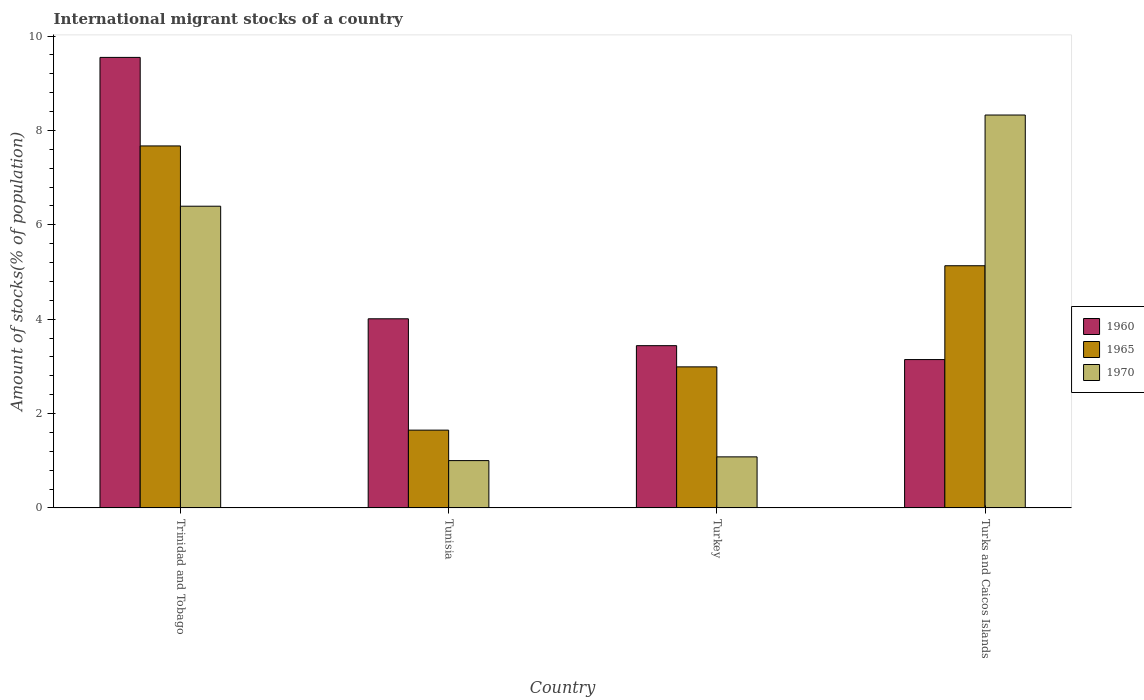How many different coloured bars are there?
Give a very brief answer. 3. How many groups of bars are there?
Ensure brevity in your answer.  4. Are the number of bars on each tick of the X-axis equal?
Offer a very short reply. Yes. What is the label of the 4th group of bars from the left?
Offer a very short reply. Turks and Caicos Islands. In how many cases, is the number of bars for a given country not equal to the number of legend labels?
Offer a terse response. 0. What is the amount of stocks in in 1965 in Trinidad and Tobago?
Your answer should be very brief. 7.67. Across all countries, what is the maximum amount of stocks in in 1960?
Your response must be concise. 9.55. Across all countries, what is the minimum amount of stocks in in 1960?
Give a very brief answer. 3.14. In which country was the amount of stocks in in 1965 maximum?
Ensure brevity in your answer.  Trinidad and Tobago. In which country was the amount of stocks in in 1960 minimum?
Give a very brief answer. Turks and Caicos Islands. What is the total amount of stocks in in 1960 in the graph?
Keep it short and to the point. 20.14. What is the difference between the amount of stocks in in 1960 in Tunisia and that in Turks and Caicos Islands?
Offer a terse response. 0.86. What is the difference between the amount of stocks in in 1970 in Turkey and the amount of stocks in in 1960 in Turks and Caicos Islands?
Offer a terse response. -2.06. What is the average amount of stocks in in 1965 per country?
Ensure brevity in your answer.  4.36. What is the difference between the amount of stocks in of/in 1960 and amount of stocks in of/in 1965 in Tunisia?
Ensure brevity in your answer.  2.36. What is the ratio of the amount of stocks in in 1960 in Trinidad and Tobago to that in Turkey?
Your answer should be compact. 2.78. What is the difference between the highest and the second highest amount of stocks in in 1965?
Provide a succinct answer. -2.14. What is the difference between the highest and the lowest amount of stocks in in 1960?
Provide a short and direct response. 6.4. What does the 2nd bar from the left in Tunisia represents?
Provide a short and direct response. 1965. What does the 3rd bar from the right in Tunisia represents?
Your response must be concise. 1960. Does the graph contain any zero values?
Provide a succinct answer. No. Where does the legend appear in the graph?
Provide a succinct answer. Center right. How many legend labels are there?
Ensure brevity in your answer.  3. What is the title of the graph?
Keep it short and to the point. International migrant stocks of a country. What is the label or title of the X-axis?
Offer a terse response. Country. What is the label or title of the Y-axis?
Ensure brevity in your answer.  Amount of stocks(% of population). What is the Amount of stocks(% of population) in 1960 in Trinidad and Tobago?
Your answer should be compact. 9.55. What is the Amount of stocks(% of population) in 1965 in Trinidad and Tobago?
Give a very brief answer. 7.67. What is the Amount of stocks(% of population) of 1970 in Trinidad and Tobago?
Your answer should be very brief. 6.39. What is the Amount of stocks(% of population) in 1960 in Tunisia?
Keep it short and to the point. 4.01. What is the Amount of stocks(% of population) of 1965 in Tunisia?
Ensure brevity in your answer.  1.65. What is the Amount of stocks(% of population) of 1970 in Tunisia?
Your answer should be compact. 1. What is the Amount of stocks(% of population) of 1960 in Turkey?
Offer a very short reply. 3.44. What is the Amount of stocks(% of population) of 1965 in Turkey?
Keep it short and to the point. 2.99. What is the Amount of stocks(% of population) in 1970 in Turkey?
Provide a short and direct response. 1.08. What is the Amount of stocks(% of population) of 1960 in Turks and Caicos Islands?
Ensure brevity in your answer.  3.14. What is the Amount of stocks(% of population) of 1965 in Turks and Caicos Islands?
Make the answer very short. 5.13. What is the Amount of stocks(% of population) of 1970 in Turks and Caicos Islands?
Provide a succinct answer. 8.33. Across all countries, what is the maximum Amount of stocks(% of population) of 1960?
Offer a terse response. 9.55. Across all countries, what is the maximum Amount of stocks(% of population) of 1965?
Ensure brevity in your answer.  7.67. Across all countries, what is the maximum Amount of stocks(% of population) of 1970?
Make the answer very short. 8.33. Across all countries, what is the minimum Amount of stocks(% of population) in 1960?
Give a very brief answer. 3.14. Across all countries, what is the minimum Amount of stocks(% of population) in 1965?
Provide a succinct answer. 1.65. Across all countries, what is the minimum Amount of stocks(% of population) in 1970?
Keep it short and to the point. 1. What is the total Amount of stocks(% of population) in 1960 in the graph?
Give a very brief answer. 20.14. What is the total Amount of stocks(% of population) of 1965 in the graph?
Offer a very short reply. 17.44. What is the total Amount of stocks(% of population) of 1970 in the graph?
Offer a very short reply. 16.81. What is the difference between the Amount of stocks(% of population) of 1960 in Trinidad and Tobago and that in Tunisia?
Ensure brevity in your answer.  5.54. What is the difference between the Amount of stocks(% of population) of 1965 in Trinidad and Tobago and that in Tunisia?
Offer a terse response. 6.02. What is the difference between the Amount of stocks(% of population) in 1970 in Trinidad and Tobago and that in Tunisia?
Offer a terse response. 5.39. What is the difference between the Amount of stocks(% of population) in 1960 in Trinidad and Tobago and that in Turkey?
Make the answer very short. 6.11. What is the difference between the Amount of stocks(% of population) in 1965 in Trinidad and Tobago and that in Turkey?
Your response must be concise. 4.68. What is the difference between the Amount of stocks(% of population) in 1970 in Trinidad and Tobago and that in Turkey?
Offer a terse response. 5.31. What is the difference between the Amount of stocks(% of population) of 1960 in Trinidad and Tobago and that in Turks and Caicos Islands?
Your answer should be compact. 6.4. What is the difference between the Amount of stocks(% of population) of 1965 in Trinidad and Tobago and that in Turks and Caicos Islands?
Offer a terse response. 2.54. What is the difference between the Amount of stocks(% of population) in 1970 in Trinidad and Tobago and that in Turks and Caicos Islands?
Your answer should be very brief. -1.93. What is the difference between the Amount of stocks(% of population) in 1960 in Tunisia and that in Turkey?
Your answer should be very brief. 0.57. What is the difference between the Amount of stocks(% of population) of 1965 in Tunisia and that in Turkey?
Give a very brief answer. -1.34. What is the difference between the Amount of stocks(% of population) in 1970 in Tunisia and that in Turkey?
Provide a short and direct response. -0.08. What is the difference between the Amount of stocks(% of population) of 1960 in Tunisia and that in Turks and Caicos Islands?
Your answer should be compact. 0.86. What is the difference between the Amount of stocks(% of population) in 1965 in Tunisia and that in Turks and Caicos Islands?
Your answer should be compact. -3.48. What is the difference between the Amount of stocks(% of population) of 1970 in Tunisia and that in Turks and Caicos Islands?
Ensure brevity in your answer.  -7.32. What is the difference between the Amount of stocks(% of population) of 1960 in Turkey and that in Turks and Caicos Islands?
Keep it short and to the point. 0.29. What is the difference between the Amount of stocks(% of population) in 1965 in Turkey and that in Turks and Caicos Islands?
Offer a very short reply. -2.14. What is the difference between the Amount of stocks(% of population) in 1970 in Turkey and that in Turks and Caicos Islands?
Offer a very short reply. -7.25. What is the difference between the Amount of stocks(% of population) of 1960 in Trinidad and Tobago and the Amount of stocks(% of population) of 1965 in Tunisia?
Offer a very short reply. 7.9. What is the difference between the Amount of stocks(% of population) in 1960 in Trinidad and Tobago and the Amount of stocks(% of population) in 1970 in Tunisia?
Offer a very short reply. 8.55. What is the difference between the Amount of stocks(% of population) of 1965 in Trinidad and Tobago and the Amount of stocks(% of population) of 1970 in Tunisia?
Ensure brevity in your answer.  6.67. What is the difference between the Amount of stocks(% of population) in 1960 in Trinidad and Tobago and the Amount of stocks(% of population) in 1965 in Turkey?
Give a very brief answer. 6.56. What is the difference between the Amount of stocks(% of population) of 1960 in Trinidad and Tobago and the Amount of stocks(% of population) of 1970 in Turkey?
Make the answer very short. 8.47. What is the difference between the Amount of stocks(% of population) in 1965 in Trinidad and Tobago and the Amount of stocks(% of population) in 1970 in Turkey?
Provide a short and direct response. 6.59. What is the difference between the Amount of stocks(% of population) in 1960 in Trinidad and Tobago and the Amount of stocks(% of population) in 1965 in Turks and Caicos Islands?
Offer a very short reply. 4.42. What is the difference between the Amount of stocks(% of population) in 1960 in Trinidad and Tobago and the Amount of stocks(% of population) in 1970 in Turks and Caicos Islands?
Offer a terse response. 1.22. What is the difference between the Amount of stocks(% of population) of 1965 in Trinidad and Tobago and the Amount of stocks(% of population) of 1970 in Turks and Caicos Islands?
Offer a terse response. -0.66. What is the difference between the Amount of stocks(% of population) in 1960 in Tunisia and the Amount of stocks(% of population) in 1965 in Turkey?
Give a very brief answer. 1.02. What is the difference between the Amount of stocks(% of population) in 1960 in Tunisia and the Amount of stocks(% of population) in 1970 in Turkey?
Give a very brief answer. 2.93. What is the difference between the Amount of stocks(% of population) in 1965 in Tunisia and the Amount of stocks(% of population) in 1970 in Turkey?
Ensure brevity in your answer.  0.57. What is the difference between the Amount of stocks(% of population) of 1960 in Tunisia and the Amount of stocks(% of population) of 1965 in Turks and Caicos Islands?
Ensure brevity in your answer.  -1.12. What is the difference between the Amount of stocks(% of population) in 1960 in Tunisia and the Amount of stocks(% of population) in 1970 in Turks and Caicos Islands?
Your answer should be compact. -4.32. What is the difference between the Amount of stocks(% of population) in 1965 in Tunisia and the Amount of stocks(% of population) in 1970 in Turks and Caicos Islands?
Keep it short and to the point. -6.68. What is the difference between the Amount of stocks(% of population) of 1960 in Turkey and the Amount of stocks(% of population) of 1965 in Turks and Caicos Islands?
Your answer should be very brief. -1.69. What is the difference between the Amount of stocks(% of population) in 1960 in Turkey and the Amount of stocks(% of population) in 1970 in Turks and Caicos Islands?
Ensure brevity in your answer.  -4.89. What is the difference between the Amount of stocks(% of population) of 1965 in Turkey and the Amount of stocks(% of population) of 1970 in Turks and Caicos Islands?
Your answer should be compact. -5.34. What is the average Amount of stocks(% of population) of 1960 per country?
Your response must be concise. 5.04. What is the average Amount of stocks(% of population) of 1965 per country?
Provide a succinct answer. 4.36. What is the average Amount of stocks(% of population) in 1970 per country?
Your response must be concise. 4.2. What is the difference between the Amount of stocks(% of population) in 1960 and Amount of stocks(% of population) in 1965 in Trinidad and Tobago?
Make the answer very short. 1.88. What is the difference between the Amount of stocks(% of population) of 1960 and Amount of stocks(% of population) of 1970 in Trinidad and Tobago?
Offer a terse response. 3.15. What is the difference between the Amount of stocks(% of population) in 1965 and Amount of stocks(% of population) in 1970 in Trinidad and Tobago?
Make the answer very short. 1.28. What is the difference between the Amount of stocks(% of population) in 1960 and Amount of stocks(% of population) in 1965 in Tunisia?
Give a very brief answer. 2.36. What is the difference between the Amount of stocks(% of population) of 1960 and Amount of stocks(% of population) of 1970 in Tunisia?
Make the answer very short. 3.01. What is the difference between the Amount of stocks(% of population) in 1965 and Amount of stocks(% of population) in 1970 in Tunisia?
Your answer should be very brief. 0.65. What is the difference between the Amount of stocks(% of population) of 1960 and Amount of stocks(% of population) of 1965 in Turkey?
Make the answer very short. 0.45. What is the difference between the Amount of stocks(% of population) of 1960 and Amount of stocks(% of population) of 1970 in Turkey?
Keep it short and to the point. 2.36. What is the difference between the Amount of stocks(% of population) of 1965 and Amount of stocks(% of population) of 1970 in Turkey?
Offer a very short reply. 1.91. What is the difference between the Amount of stocks(% of population) of 1960 and Amount of stocks(% of population) of 1965 in Turks and Caicos Islands?
Ensure brevity in your answer.  -1.99. What is the difference between the Amount of stocks(% of population) in 1960 and Amount of stocks(% of population) in 1970 in Turks and Caicos Islands?
Make the answer very short. -5.18. What is the difference between the Amount of stocks(% of population) of 1965 and Amount of stocks(% of population) of 1970 in Turks and Caicos Islands?
Offer a terse response. -3.19. What is the ratio of the Amount of stocks(% of population) in 1960 in Trinidad and Tobago to that in Tunisia?
Keep it short and to the point. 2.38. What is the ratio of the Amount of stocks(% of population) of 1965 in Trinidad and Tobago to that in Tunisia?
Offer a very short reply. 4.65. What is the ratio of the Amount of stocks(% of population) of 1970 in Trinidad and Tobago to that in Tunisia?
Your response must be concise. 6.37. What is the ratio of the Amount of stocks(% of population) in 1960 in Trinidad and Tobago to that in Turkey?
Your response must be concise. 2.78. What is the ratio of the Amount of stocks(% of population) in 1965 in Trinidad and Tobago to that in Turkey?
Your answer should be compact. 2.57. What is the ratio of the Amount of stocks(% of population) of 1970 in Trinidad and Tobago to that in Turkey?
Your response must be concise. 5.91. What is the ratio of the Amount of stocks(% of population) in 1960 in Trinidad and Tobago to that in Turks and Caicos Islands?
Keep it short and to the point. 3.04. What is the ratio of the Amount of stocks(% of population) in 1965 in Trinidad and Tobago to that in Turks and Caicos Islands?
Your answer should be very brief. 1.49. What is the ratio of the Amount of stocks(% of population) of 1970 in Trinidad and Tobago to that in Turks and Caicos Islands?
Provide a short and direct response. 0.77. What is the ratio of the Amount of stocks(% of population) of 1960 in Tunisia to that in Turkey?
Give a very brief answer. 1.17. What is the ratio of the Amount of stocks(% of population) in 1965 in Tunisia to that in Turkey?
Your answer should be very brief. 0.55. What is the ratio of the Amount of stocks(% of population) of 1970 in Tunisia to that in Turkey?
Offer a terse response. 0.93. What is the ratio of the Amount of stocks(% of population) of 1960 in Tunisia to that in Turks and Caicos Islands?
Your response must be concise. 1.27. What is the ratio of the Amount of stocks(% of population) of 1965 in Tunisia to that in Turks and Caicos Islands?
Provide a succinct answer. 0.32. What is the ratio of the Amount of stocks(% of population) of 1970 in Tunisia to that in Turks and Caicos Islands?
Your answer should be very brief. 0.12. What is the ratio of the Amount of stocks(% of population) in 1960 in Turkey to that in Turks and Caicos Islands?
Offer a terse response. 1.09. What is the ratio of the Amount of stocks(% of population) in 1965 in Turkey to that in Turks and Caicos Islands?
Offer a very short reply. 0.58. What is the ratio of the Amount of stocks(% of population) of 1970 in Turkey to that in Turks and Caicos Islands?
Your answer should be compact. 0.13. What is the difference between the highest and the second highest Amount of stocks(% of population) of 1960?
Give a very brief answer. 5.54. What is the difference between the highest and the second highest Amount of stocks(% of population) of 1965?
Your answer should be very brief. 2.54. What is the difference between the highest and the second highest Amount of stocks(% of population) in 1970?
Provide a short and direct response. 1.93. What is the difference between the highest and the lowest Amount of stocks(% of population) of 1960?
Your answer should be very brief. 6.4. What is the difference between the highest and the lowest Amount of stocks(% of population) in 1965?
Ensure brevity in your answer.  6.02. What is the difference between the highest and the lowest Amount of stocks(% of population) of 1970?
Keep it short and to the point. 7.32. 